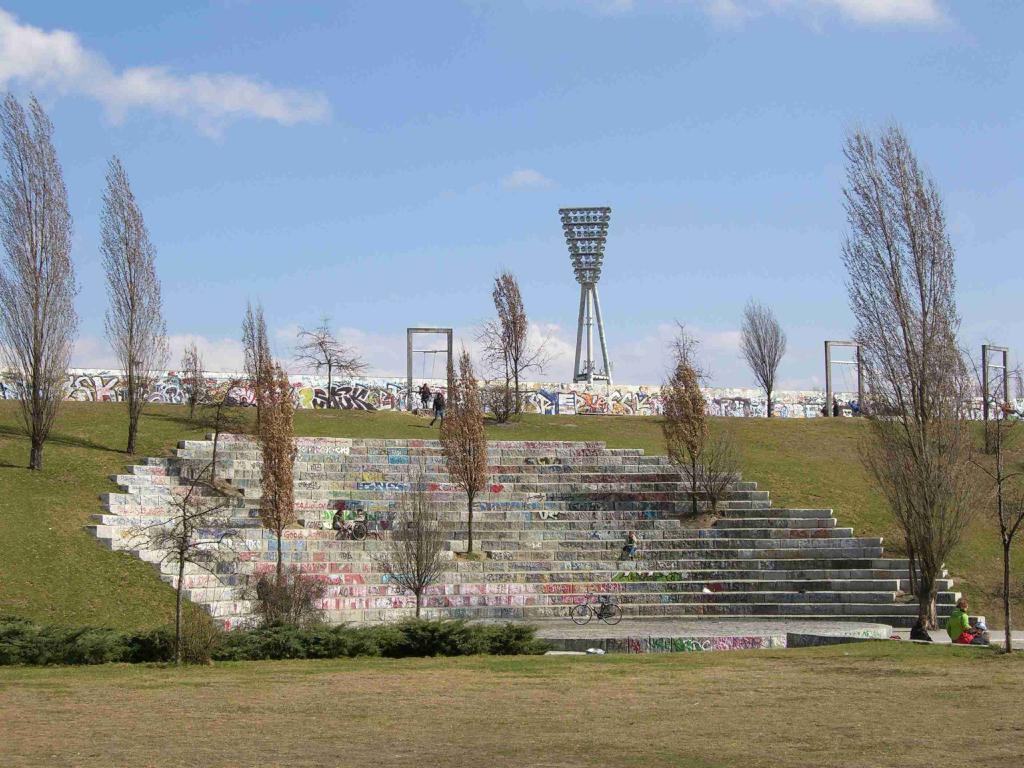Please provide a concise description of this image. In this picture we can see the grass, plants, bicycle, trees, walls with paintings on it, arches, tower, steps and a person sitting and two people and in the background we can see the sky with clouds. 